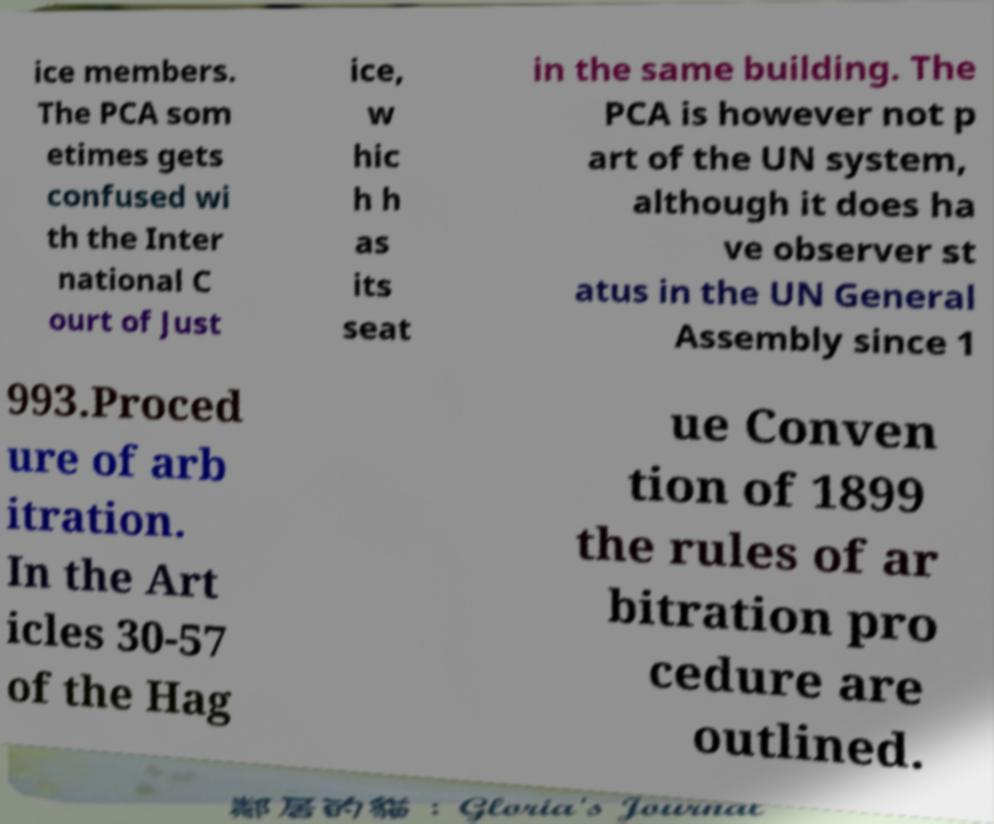Can you read and provide the text displayed in the image?This photo seems to have some interesting text. Can you extract and type it out for me? ice members. The PCA som etimes gets confused wi th the Inter national C ourt of Just ice, w hic h h as its seat in the same building. The PCA is however not p art of the UN system, although it does ha ve observer st atus in the UN General Assembly since 1 993.Proced ure of arb itration. In the Art icles 30-57 of the Hag ue Conven tion of 1899 the rules of ar bitration pro cedure are outlined. 